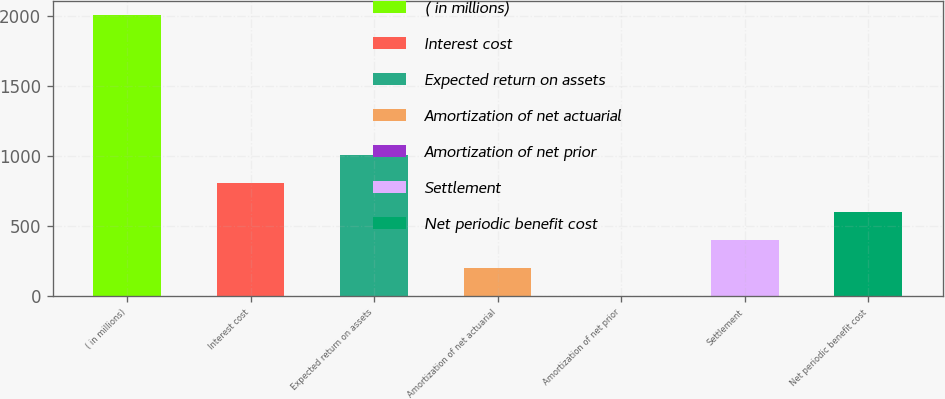Convert chart. <chart><loc_0><loc_0><loc_500><loc_500><bar_chart><fcel>( in millions)<fcel>Interest cost<fcel>Expected return on assets<fcel>Amortization of net actuarial<fcel>Amortization of net prior<fcel>Settlement<fcel>Net periodic benefit cost<nl><fcel>2007<fcel>803.4<fcel>1004<fcel>201.6<fcel>1<fcel>402.2<fcel>602.8<nl></chart> 